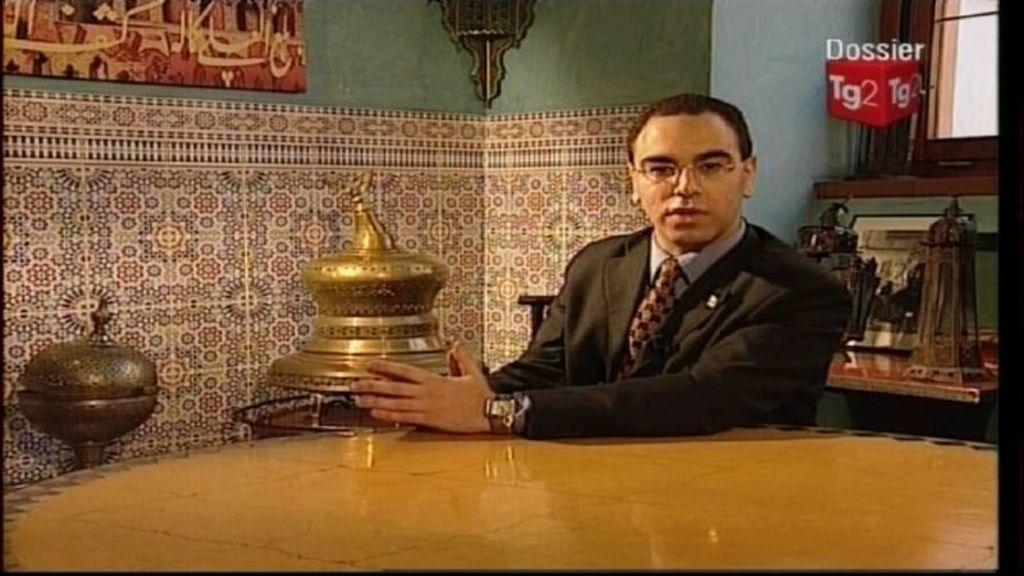What is the man in the image doing? The man is sitting on a chair in the image. What can be seen on the table in the image? There are antique pieces on a table in the image. What is hanging on the wall in the image? There is a photo frame on the wall in the image. What type of alarm is ringing in the image? There is no alarm present in the image. Who is the creator of the antique pieces on the table? The creator of the antique pieces is not mentioned in the image. 